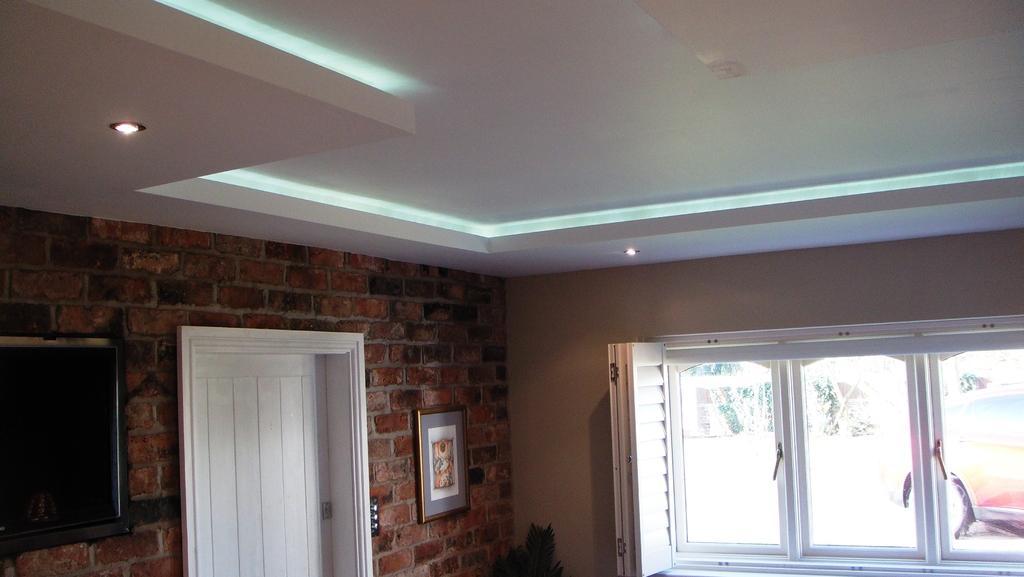Can you describe this image briefly? In this image, we can see the wall, photo frame, door, glass windows with handles, television and houseplant. Through the glasses we can see plants and vehicle. At the top of the image, we can see the ceiling and lights.  